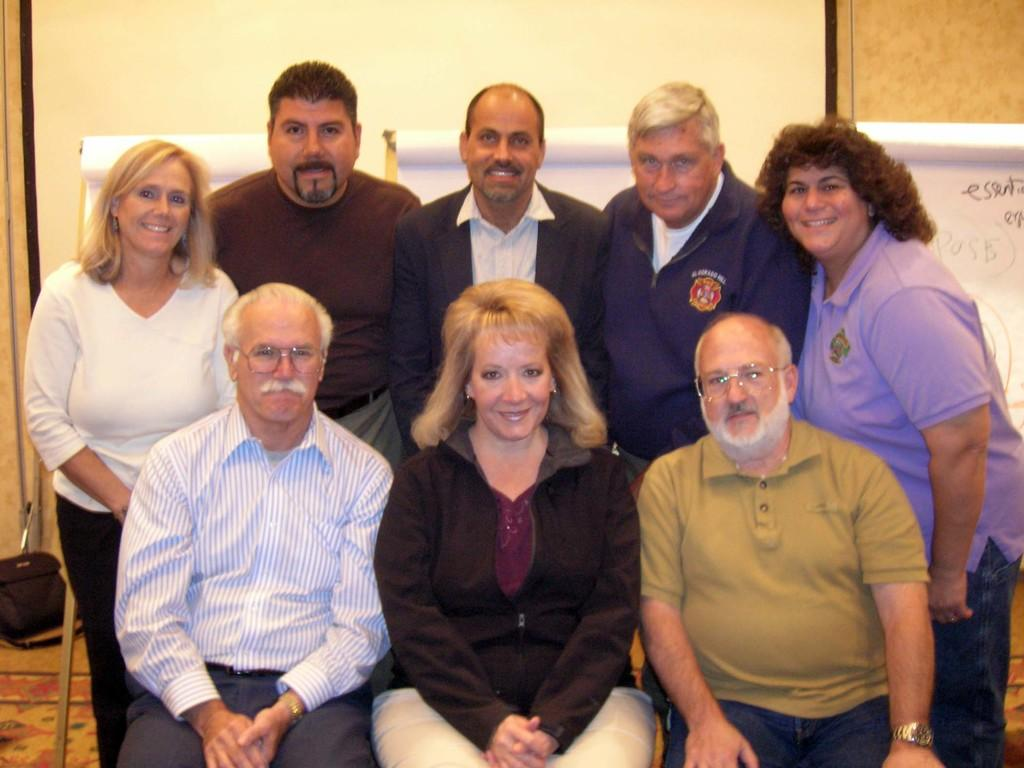What are the persons in the image doing? The persons in the image are sitting on chairs and standing on the floor. What can be seen in the background of the image? There are canvas boards with text on them in the background of the image. What else is present on the floor in the background of the image? There is a bag on the floor in the background of the image. How many babies are crawling on the floor in the image? There are no babies present in the image; it only shows persons sitting on chairs and standing on the floor. 